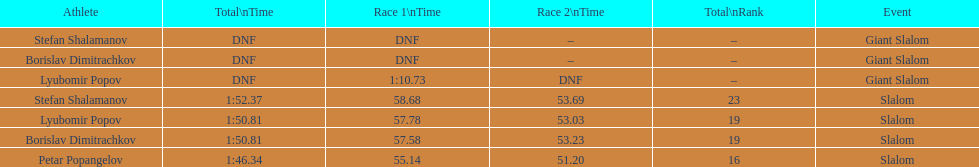How long did it take for lyubomir popov to finish the giant slalom in race 1? 1:10.73. 